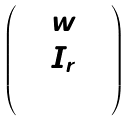<formula> <loc_0><loc_0><loc_500><loc_500>\begin{pmatrix} 1 & w & \\ & I _ { r } & \\ & & 1 \end{pmatrix}</formula> 